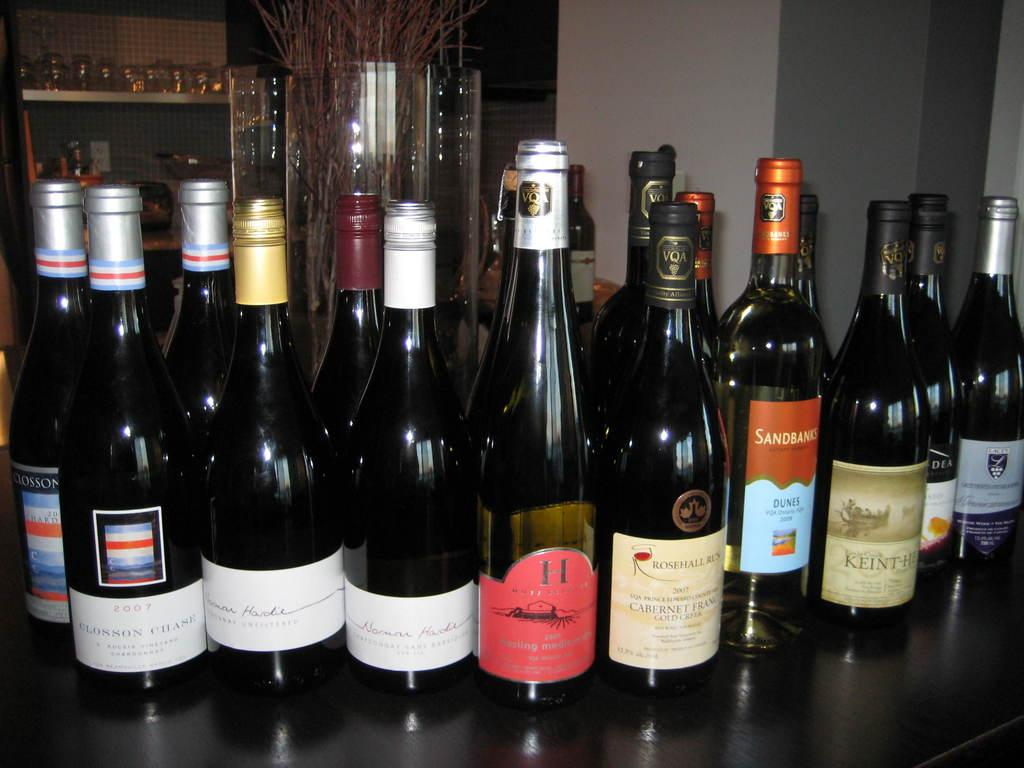<image>
Present a compact description of the photo's key features. the letter H is on one of the wine bottles 